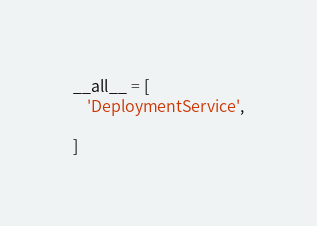Convert code to text. <code><loc_0><loc_0><loc_500><loc_500><_Python_>
__all__ = [
    'DeploymentService',

]
</code> 